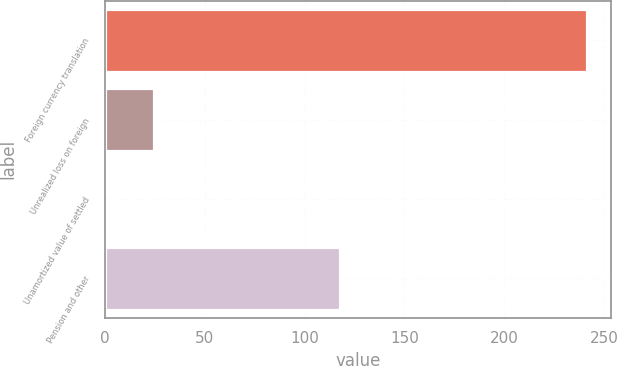Convert chart. <chart><loc_0><loc_0><loc_500><loc_500><bar_chart><fcel>Foreign currency translation<fcel>Unrealized loss on foreign<fcel>Unamortized value of settled<fcel>Pension and other<nl><fcel>241.6<fcel>24.7<fcel>0.6<fcel>117.8<nl></chart> 